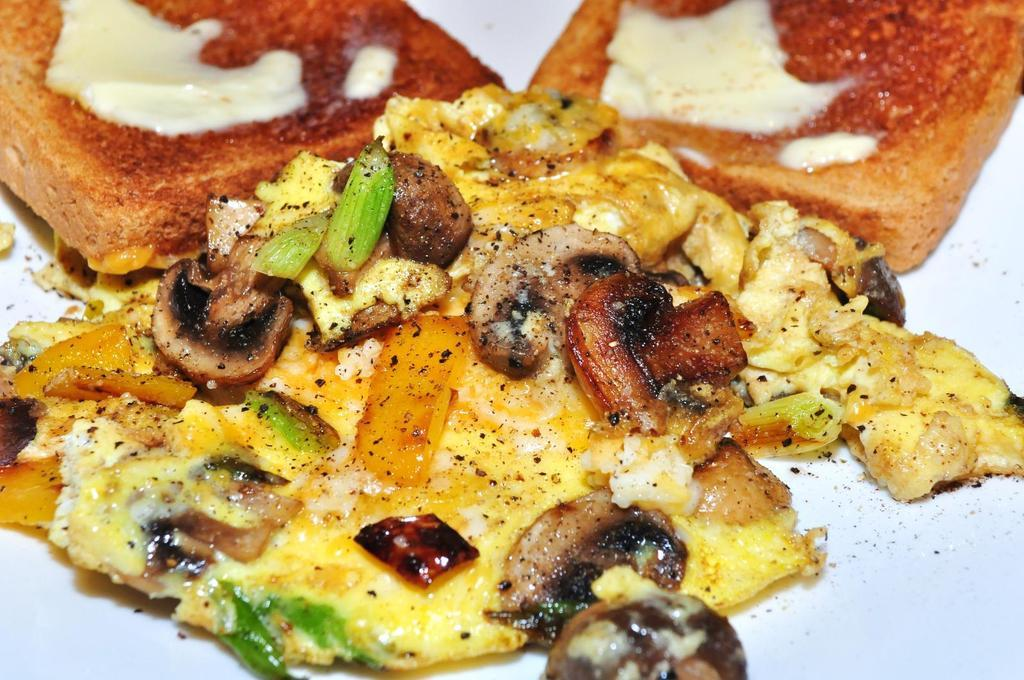What is the main subject of the image? The main subject of the image is food. How is the food presented in the image? The food is on an object that resembles a plate. What type of beast can be seen wearing apparel in the park in the image? There is no beast, apparel, or park present in the image; it only features food on a plate-like object. 